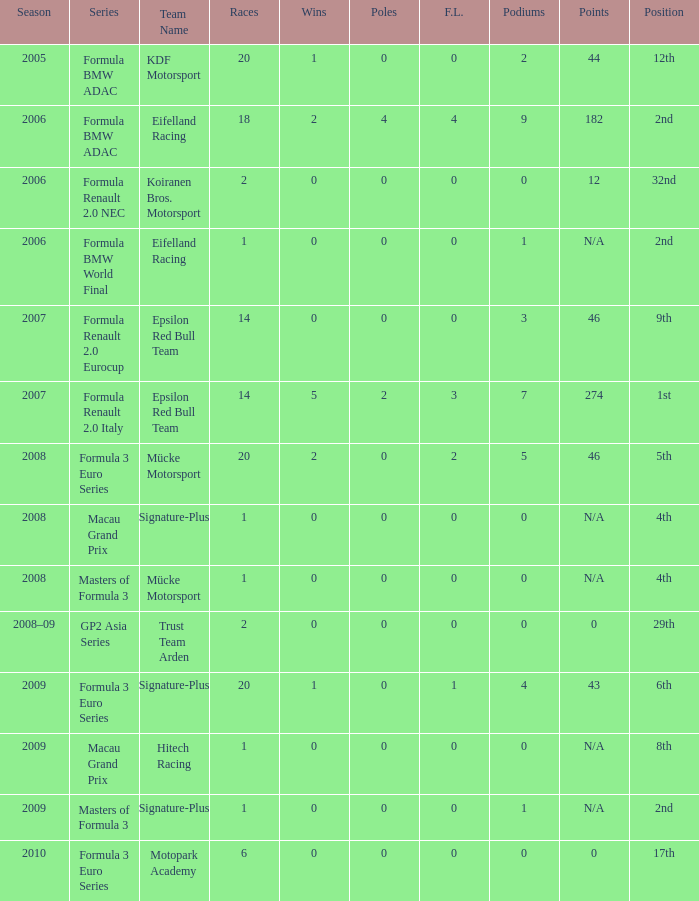What is the average number of podiums in the 32nd position with less than 0 wins? None. 